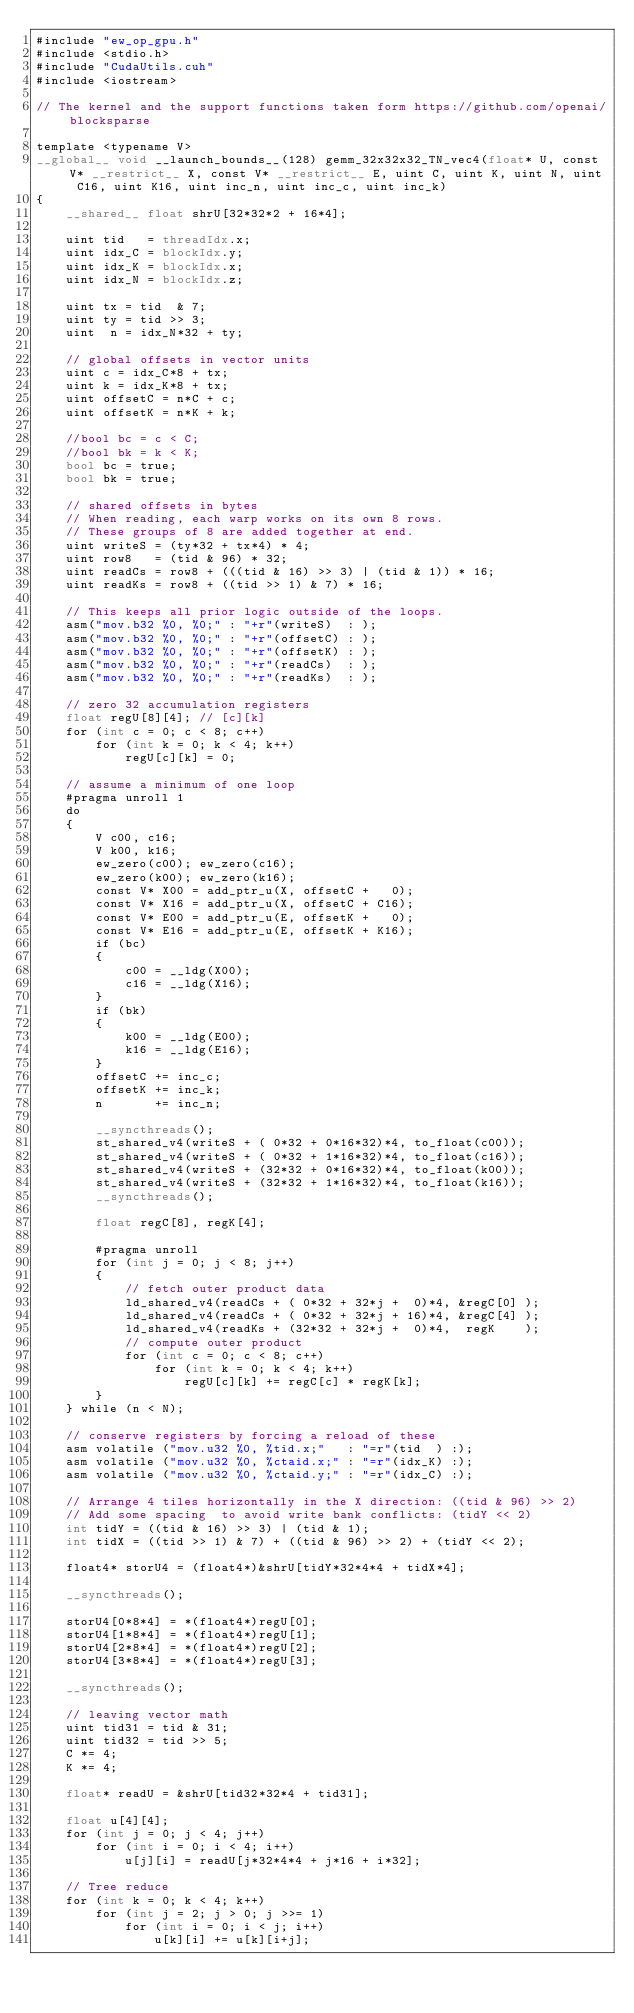Convert code to text. <code><loc_0><loc_0><loc_500><loc_500><_Cuda_>#include "ew_op_gpu.h"
#include <stdio.h>
#include "CudaUtils.cuh"
#include <iostream>

// The kernel and the support functions taken form https://github.com/openai/blocksparse

template <typename V>
__global__ void __launch_bounds__(128) gemm_32x32x32_TN_vec4(float* U, const V* __restrict__ X, const V* __restrict__ E, uint C, uint K, uint N, uint C16, uint K16, uint inc_n, uint inc_c, uint inc_k)
{
    __shared__ float shrU[32*32*2 + 16*4];

    uint tid   = threadIdx.x;
    uint idx_C = blockIdx.y;
    uint idx_K = blockIdx.x;
    uint idx_N = blockIdx.z;

    uint tx = tid  & 7;
    uint ty = tid >> 3;
    uint  n = idx_N*32 + ty;

    // global offsets in vector units
    uint c = idx_C*8 + tx;
    uint k = idx_K*8 + tx;
    uint offsetC = n*C + c;
    uint offsetK = n*K + k;

    //bool bc = c < C;
    //bool bk = k < K;
    bool bc = true;
    bool bk = true;

    // shared offsets in bytes
    // When reading, each warp works on its own 8 rows.
    // These groups of 8 are added together at end.
    uint writeS = (ty*32 + tx*4) * 4;
    uint row8   = (tid & 96) * 32;
    uint readCs = row8 + (((tid & 16) >> 3) | (tid & 1)) * 16;
    uint readKs = row8 + ((tid >> 1) & 7) * 16;

    // This keeps all prior logic outside of the loops.
    asm("mov.b32 %0, %0;" : "+r"(writeS)  : );
    asm("mov.b32 %0, %0;" : "+r"(offsetC) : );
    asm("mov.b32 %0, %0;" : "+r"(offsetK) : );
    asm("mov.b32 %0, %0;" : "+r"(readCs)  : );
    asm("mov.b32 %0, %0;" : "+r"(readKs)  : );

    // zero 32 accumulation registers
    float regU[8][4]; // [c][k]
    for (int c = 0; c < 8; c++)
        for (int k = 0; k < 4; k++)
            regU[c][k] = 0;

    // assume a minimum of one loop
    #pragma unroll 1
    do
    {
        V c00, c16;
        V k00, k16;
        ew_zero(c00); ew_zero(c16);
        ew_zero(k00); ew_zero(k16);
        const V* X00 = add_ptr_u(X, offsetC +   0);
        const V* X16 = add_ptr_u(X, offsetC + C16);
        const V* E00 = add_ptr_u(E, offsetK +   0);
        const V* E16 = add_ptr_u(E, offsetK + K16);
        if (bc)
        {
            c00 = __ldg(X00);
            c16 = __ldg(X16);
        }
        if (bk)
        {
            k00 = __ldg(E00);
            k16 = __ldg(E16);
        }
        offsetC += inc_c;
        offsetK += inc_k;
        n       += inc_n;

        __syncthreads();
        st_shared_v4(writeS + ( 0*32 + 0*16*32)*4, to_float(c00));
        st_shared_v4(writeS + ( 0*32 + 1*16*32)*4, to_float(c16));
        st_shared_v4(writeS + (32*32 + 0*16*32)*4, to_float(k00));
        st_shared_v4(writeS + (32*32 + 1*16*32)*4, to_float(k16));
        __syncthreads();

        float regC[8], regK[4];

        #pragma unroll
        for (int j = 0; j < 8; j++)
        {
            // fetch outer product data
            ld_shared_v4(readCs + ( 0*32 + 32*j +  0)*4, &regC[0] );
            ld_shared_v4(readCs + ( 0*32 + 32*j + 16)*4, &regC[4] );
            ld_shared_v4(readKs + (32*32 + 32*j +  0)*4,  regK    );
            // compute outer product
            for (int c = 0; c < 8; c++)
                for (int k = 0; k < 4; k++)
                    regU[c][k] += regC[c] * regK[k];
        }
    } while (n < N);

    // conserve registers by forcing a reload of these
    asm volatile ("mov.u32 %0, %tid.x;"   : "=r"(tid  ) :);
    asm volatile ("mov.u32 %0, %ctaid.x;" : "=r"(idx_K) :);
    asm volatile ("mov.u32 %0, %ctaid.y;" : "=r"(idx_C) :);

    // Arrange 4 tiles horizontally in the X direction: ((tid & 96) >> 2)
    // Add some spacing  to avoid write bank conflicts: (tidY << 2)
    int tidY = ((tid & 16) >> 3) | (tid & 1);
    int tidX = ((tid >> 1) & 7) + ((tid & 96) >> 2) + (tidY << 2);

    float4* storU4 = (float4*)&shrU[tidY*32*4*4 + tidX*4];

    __syncthreads();

    storU4[0*8*4] = *(float4*)regU[0];
    storU4[1*8*4] = *(float4*)regU[1];
    storU4[2*8*4] = *(float4*)regU[2];
    storU4[3*8*4] = *(float4*)regU[3];

    __syncthreads();

    // leaving vector math
    uint tid31 = tid & 31;
    uint tid32 = tid >> 5;
    C *= 4;
    K *= 4;

    float* readU = &shrU[tid32*32*4 + tid31];

    float u[4][4];
    for (int j = 0; j < 4; j++)
        for (int i = 0; i < 4; i++)
            u[j][i] = readU[j*32*4*4 + j*16 + i*32];

    // Tree reduce
    for (int k = 0; k < 4; k++)
        for (int j = 2; j > 0; j >>= 1)
            for (int i = 0; i < j; i++)
                u[k][i] += u[k][i+j];
</code> 